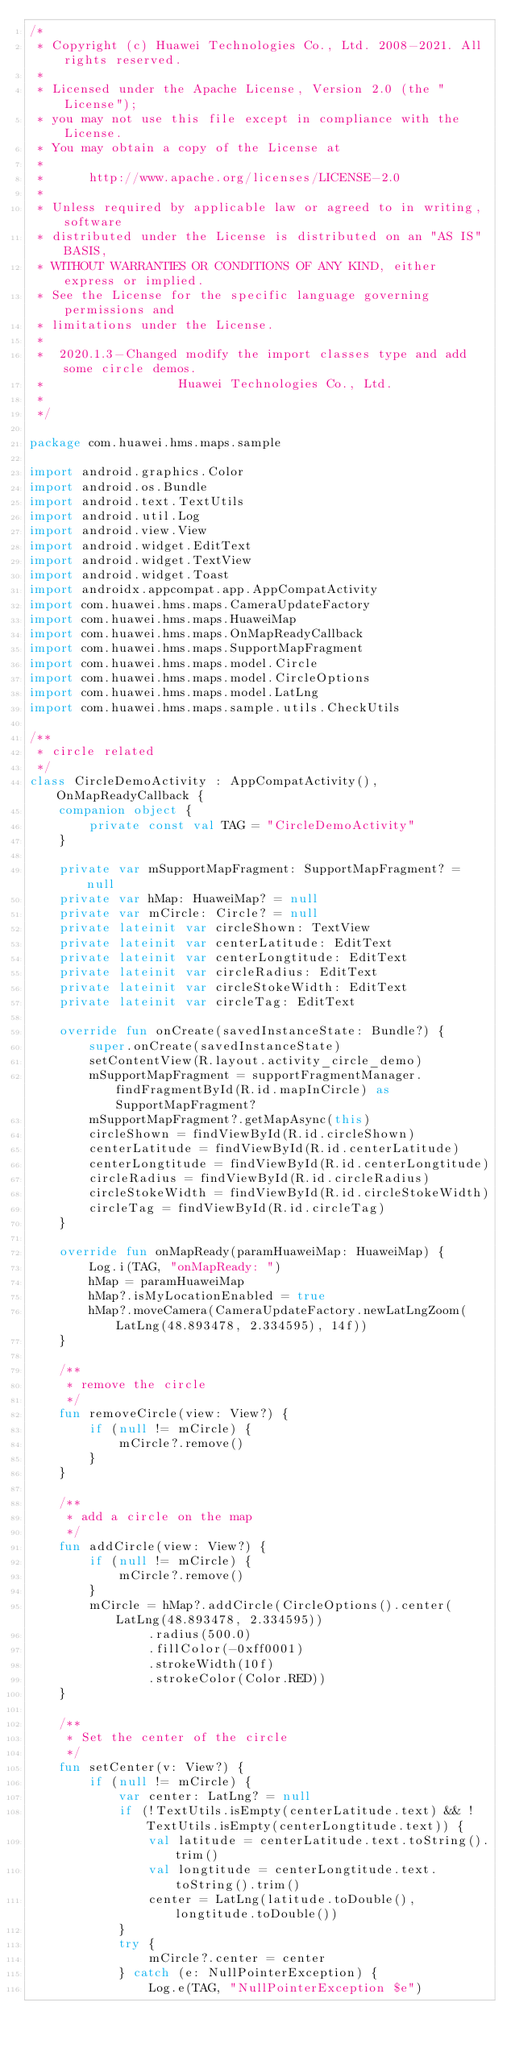<code> <loc_0><loc_0><loc_500><loc_500><_Kotlin_>/*
 * Copyright (c) Huawei Technologies Co., Ltd. 2008-2021. All rights reserved.
 *
 * Licensed under the Apache License, Version 2.0 (the "License");
 * you may not use this file except in compliance with the License.
 * You may obtain a copy of the License at
 *
 *      http://www.apache.org/licenses/LICENSE-2.0
 *
 * Unless required by applicable law or agreed to in writing, software
 * distributed under the License is distributed on an "AS IS" BASIS,
 * WITHOUT WARRANTIES OR CONDITIONS OF ANY KIND, either express or implied.
 * See the License for the specific language governing permissions and
 * limitations under the License.
 *
 *  2020.1.3-Changed modify the import classes type and add some circle demos.
 *                  Huawei Technologies Co., Ltd.
 *
 */

package com.huawei.hms.maps.sample

import android.graphics.Color
import android.os.Bundle
import android.text.TextUtils
import android.util.Log
import android.view.View
import android.widget.EditText
import android.widget.TextView
import android.widget.Toast
import androidx.appcompat.app.AppCompatActivity
import com.huawei.hms.maps.CameraUpdateFactory
import com.huawei.hms.maps.HuaweiMap
import com.huawei.hms.maps.OnMapReadyCallback
import com.huawei.hms.maps.SupportMapFragment
import com.huawei.hms.maps.model.Circle
import com.huawei.hms.maps.model.CircleOptions
import com.huawei.hms.maps.model.LatLng
import com.huawei.hms.maps.sample.utils.CheckUtils

/**
 * circle related
 */
class CircleDemoActivity : AppCompatActivity(), OnMapReadyCallback {
    companion object {
        private const val TAG = "CircleDemoActivity"
    }

    private var mSupportMapFragment: SupportMapFragment? = null
    private var hMap: HuaweiMap? = null
    private var mCircle: Circle? = null
    private lateinit var circleShown: TextView
    private lateinit var centerLatitude: EditText
    private lateinit var centerLongtitude: EditText
    private lateinit var circleRadius: EditText
    private lateinit var circleStokeWidth: EditText
    private lateinit var circleTag: EditText

    override fun onCreate(savedInstanceState: Bundle?) {
        super.onCreate(savedInstanceState)
        setContentView(R.layout.activity_circle_demo)
        mSupportMapFragment = supportFragmentManager.findFragmentById(R.id.mapInCircle) as SupportMapFragment?
        mSupportMapFragment?.getMapAsync(this)
        circleShown = findViewById(R.id.circleShown)
        centerLatitude = findViewById(R.id.centerLatitude)
        centerLongtitude = findViewById(R.id.centerLongtitude)
        circleRadius = findViewById(R.id.circleRadius)
        circleStokeWidth = findViewById(R.id.circleStokeWidth)
        circleTag = findViewById(R.id.circleTag)
    }

    override fun onMapReady(paramHuaweiMap: HuaweiMap) {
        Log.i(TAG, "onMapReady: ")
        hMap = paramHuaweiMap
        hMap?.isMyLocationEnabled = true
        hMap?.moveCamera(CameraUpdateFactory.newLatLngZoom(LatLng(48.893478, 2.334595), 14f))
    }

    /**
     * remove the circle
     */
    fun removeCircle(view: View?) {
        if (null != mCircle) {
            mCircle?.remove()
        }
    }

    /**
     * add a circle on the map
     */
    fun addCircle(view: View?) {
        if (null != mCircle) {
            mCircle?.remove()
        }
        mCircle = hMap?.addCircle(CircleOptions().center(LatLng(48.893478, 2.334595))
                .radius(500.0)
                .fillColor(-0xff0001)
                .strokeWidth(10f)
                .strokeColor(Color.RED))
    }

    /**
     * Set the center of the circle
     */
    fun setCenter(v: View?) {
        if (null != mCircle) {
            var center: LatLng? = null
            if (!TextUtils.isEmpty(centerLatitude.text) && !TextUtils.isEmpty(centerLongtitude.text)) {
                val latitude = centerLatitude.text.toString().trim()
                val longtitude = centerLongtitude.text.toString().trim()
                center = LatLng(latitude.toDouble(), longtitude.toDouble())
            }
            try {
                mCircle?.center = center
            } catch (e: NullPointerException) {
                Log.e(TAG, "NullPointerException $e")</code> 